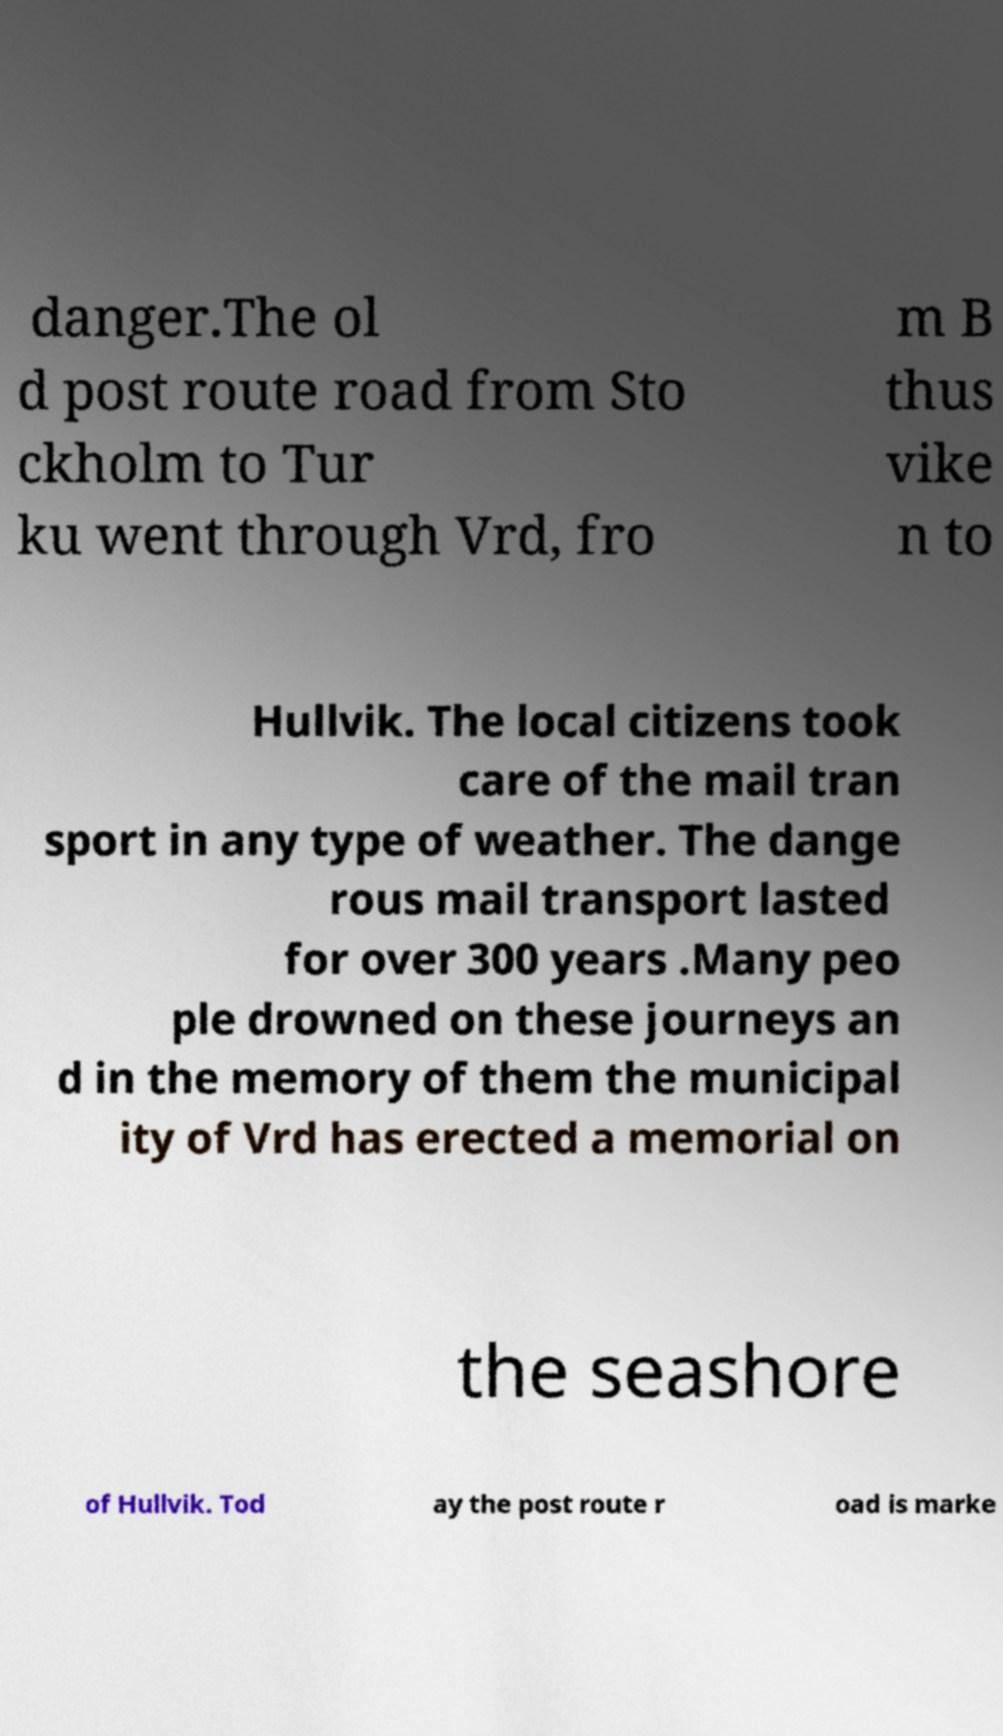Can you accurately transcribe the text from the provided image for me? danger.The ol d post route road from Sto ckholm to Tur ku went through Vrd, fro m B thus vike n to Hullvik. The local citizens took care of the mail tran sport in any type of weather. The dange rous mail transport lasted for over 300 years .Many peo ple drowned on these journeys an d in the memory of them the municipal ity of Vrd has erected a memorial on the seashore of Hullvik. Tod ay the post route r oad is marke 